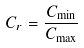Convert formula to latex. <formula><loc_0><loc_0><loc_500><loc_500>C _ { r } = \frac { C _ { \min } } { C _ { \max } }</formula> 